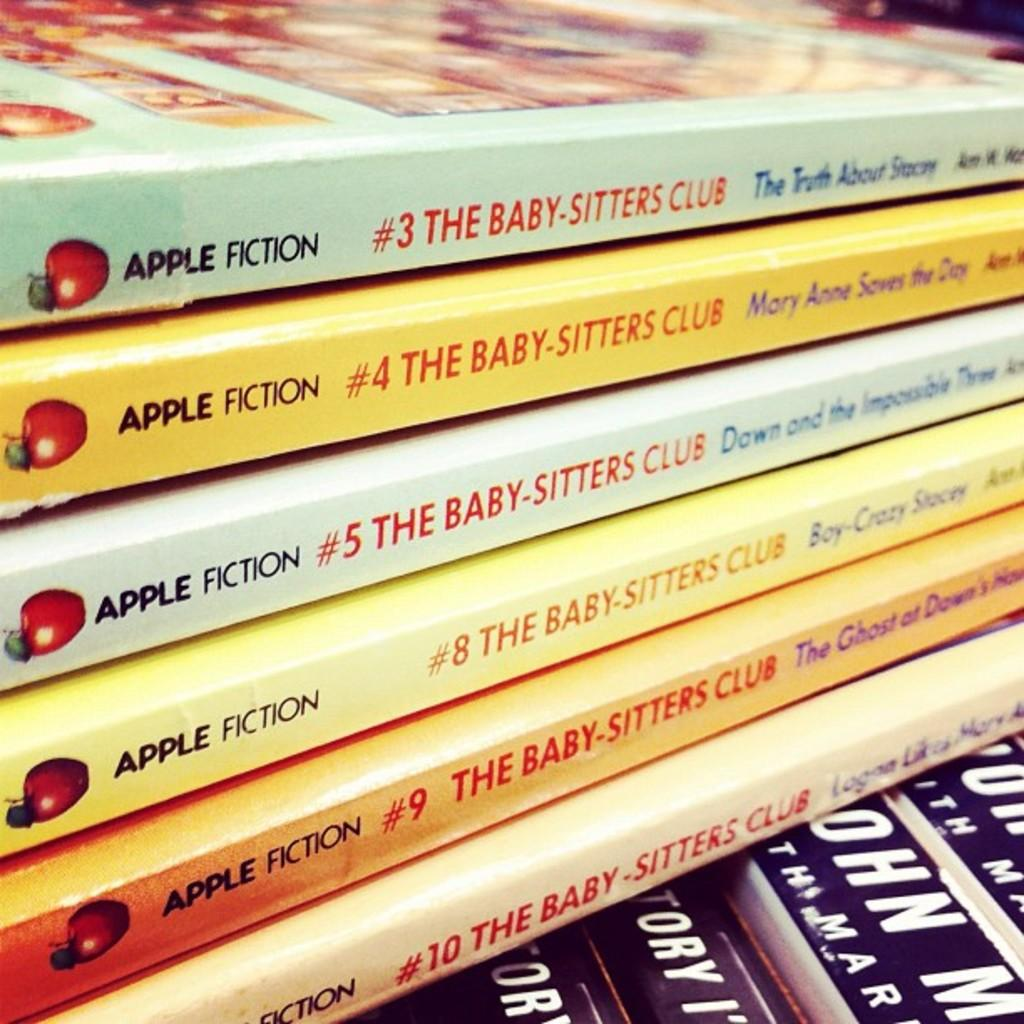<image>
Relay a brief, clear account of the picture shown. Six volumes of The Baby-Sitters Club are stacked on top of other books. 